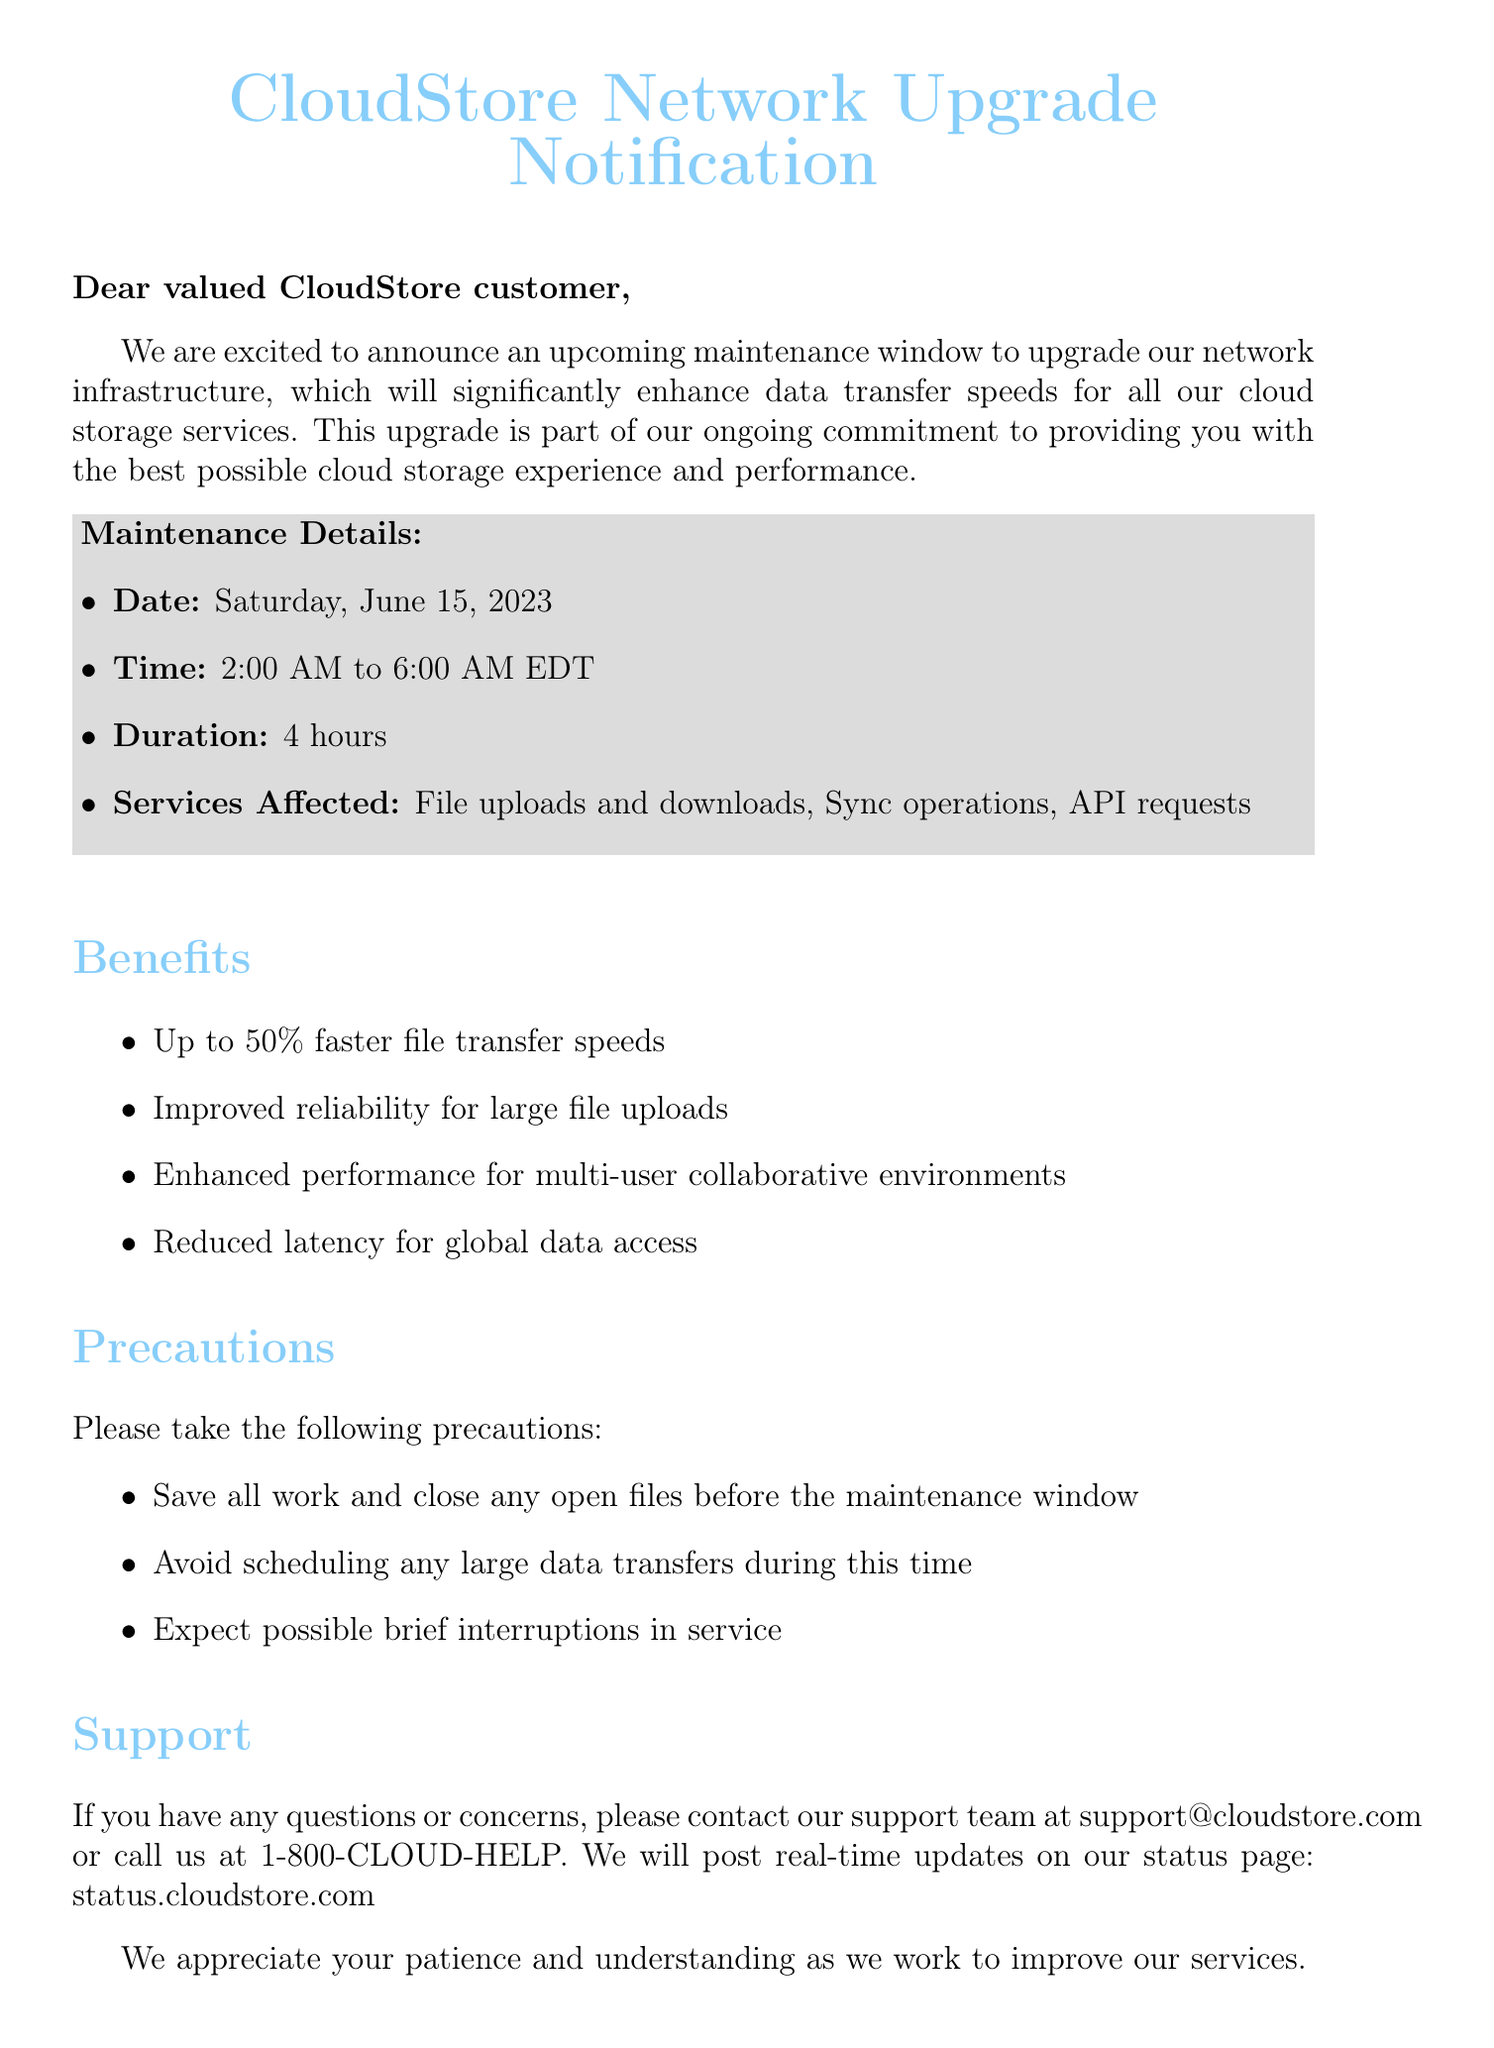What is the date of the maintenance window? The date of the maintenance window is explicitly mentioned in the document.
Answer: Saturday, June 15, 2023 What time will the maintenance start? The document states the exact time the maintenance will begin.
Answer: 2:00 AM How long will the maintenance last? The document provides information on the duration of the maintenance window.
Answer: 4 hours What services will be affected during the maintenance? The document lists the services that will be impacted by the maintenance.
Answer: File uploads and downloads, Sync operations, API requests What is one benefit of the network upgrade? The document highlights several benefits of the network upgrade, and this question seeks one specific example.
Answer: Up to 50% faster file transfer speeds What precaution should customers take before the maintenance window? The document advises customers on actions to take before the maintenance begins.
Answer: Save all work and close any open files What support contact method is provided? The document offers a method for customers to reach out for support during the maintenance period.
Answer: support@cloudstore.com What is the purpose of this maintenance? The document explains the reason for the upcoming maintenance.
Answer: To upgrade our network infrastructure How will customers receive updates during the maintenance? The document specifies how customers can stay informed about the maintenance status.
Answer: status.cloudstore.com 